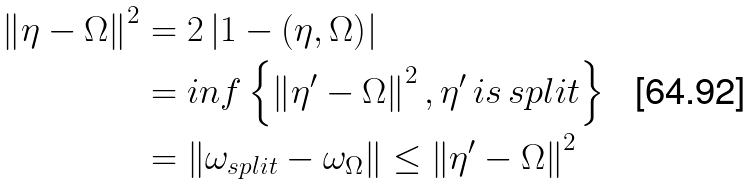Convert formula to latex. <formula><loc_0><loc_0><loc_500><loc_500>\left \| \eta - \Omega \right \| ^ { 2 } & = 2 \left | 1 - \left ( \eta , \Omega \right ) \right | \\ & = i n f \left \{ \left \| \eta ^ { \prime } - \Omega \right \| ^ { 2 } , \eta ^ { \prime } \, i s \, s p l i t \right \} \\ & = \left \| \omega _ { s p l i t } - \omega _ { \Omega } \right \| \leq \left \| \eta ^ { \prime } - \Omega \right \| ^ { 2 }</formula> 